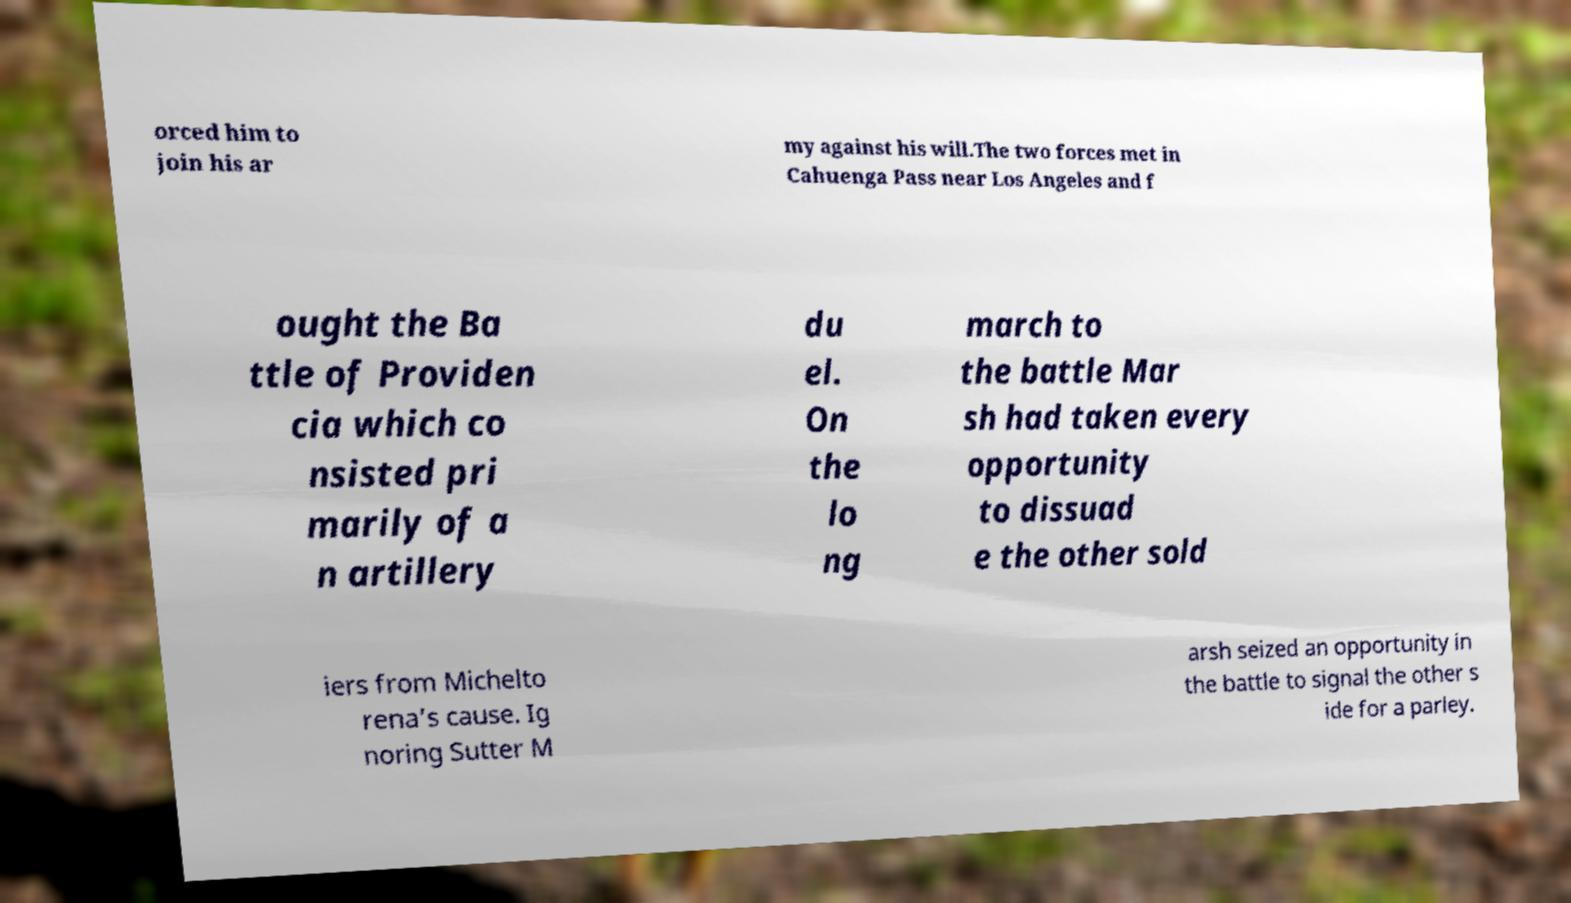I need the written content from this picture converted into text. Can you do that? orced him to join his ar my against his will.The two forces met in Cahuenga Pass near Los Angeles and f ought the Ba ttle of Providen cia which co nsisted pri marily of a n artillery du el. On the lo ng march to the battle Mar sh had taken every opportunity to dissuad e the other sold iers from Michelto rena’s cause. Ig noring Sutter M arsh seized an opportunity in the battle to signal the other s ide for a parley. 